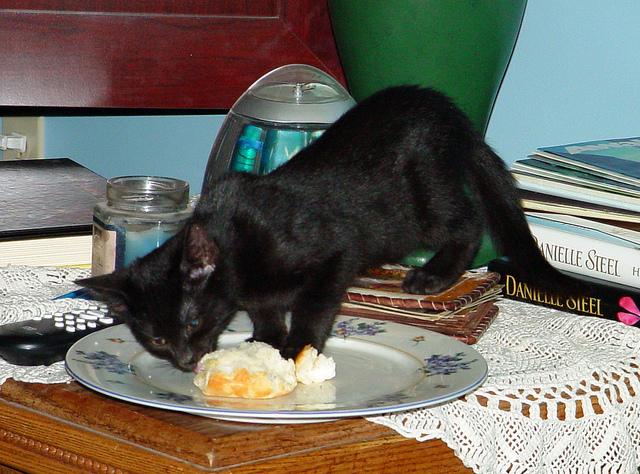Is this natural food they have found?
Quick response, please. No. Should the cat be eating from this plate?
Keep it brief. No. What is the cat eating?
Quick response, please. Biscuit. What kind of decorations has the dish?
Concise answer only. Flowers. Why is there nothing on the plate?
Keep it brief. There is. 